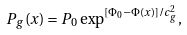Convert formula to latex. <formula><loc_0><loc_0><loc_500><loc_500>P _ { g } ( x ) = P _ { 0 } \exp ^ { [ \Phi _ { 0 } - \Phi ( x ) ] / c ^ { 2 } _ { g } } ,</formula> 